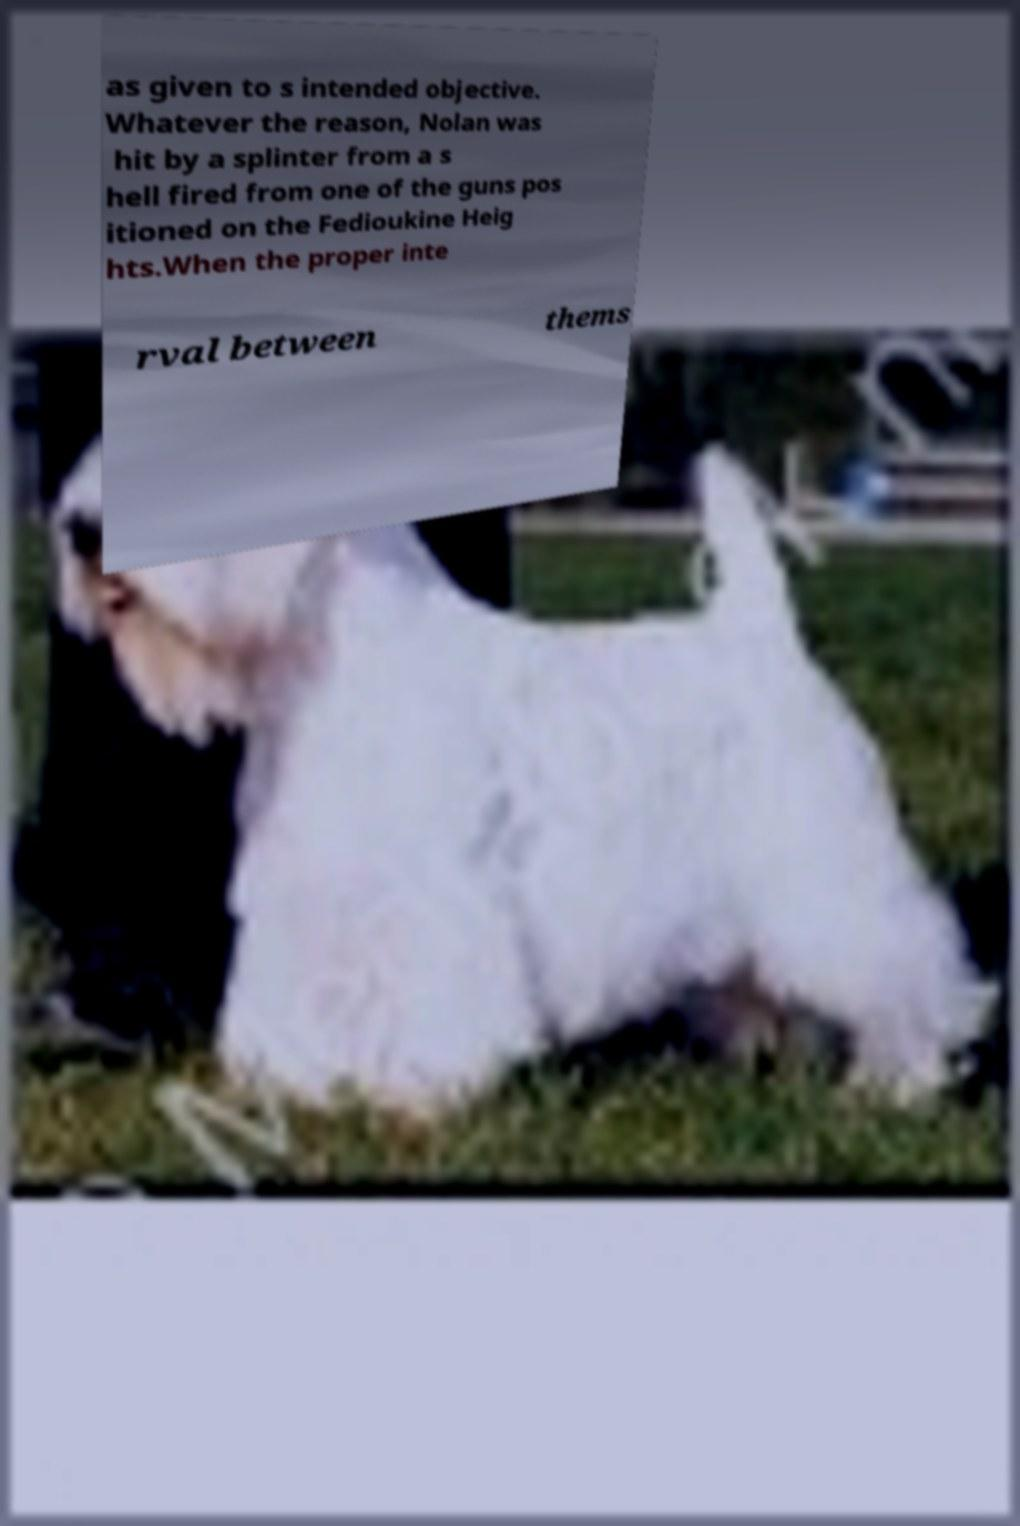Please identify and transcribe the text found in this image. as given to s intended objective. Whatever the reason, Nolan was hit by a splinter from a s hell fired from one of the guns pos itioned on the Fedioukine Heig hts.When the proper inte rval between thems 